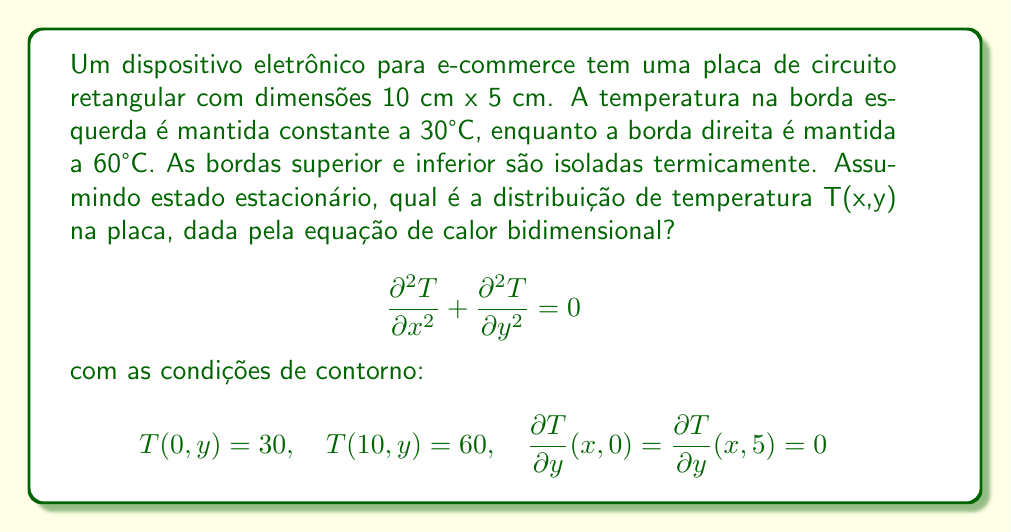Provide a solution to this math problem. Para resolver este problema, seguiremos os seguintes passos:

1) A equação de calor bidimensional em estado estacionário é:

   $$\frac{\partial^2 T}{\partial x^2} + \frac{\partial^2 T}{\partial y^2} = 0$$

2) Dadas as condições de contorno, podemos assumir que a temperatura varia apenas na direção x. Portanto, $\frac{\partial^2 T}{\partial y^2} = 0$, e a equação se reduz a:

   $$\frac{d^2 T}{dx^2} = 0$$

3) A solução geral desta equação é:

   $$T(x) = Ax + B$$

   onde A e B são constantes a serem determinadas.

4) Usando as condições de contorno:

   $$T(0) = 30 \implies B = 30$$
   $$T(10) = 60 \implies 10A + 30 = 60 \implies A = 3$$

5) Portanto, a distribuição de temperatura é:

   $$T(x) = 3x + 30$$

6) Esta função satisfaz todas as condições de contorno:
   - $T(0) = 30$
   - $T(10) = 60$
   - A temperatura não depende de y, então $\frac{\partial T}{\partial y} = 0$ em todas as partes, satisfazendo as condições de isolamento térmico nas bordas superior e inferior.
Answer: $T(x,y) = 3x + 30$ 